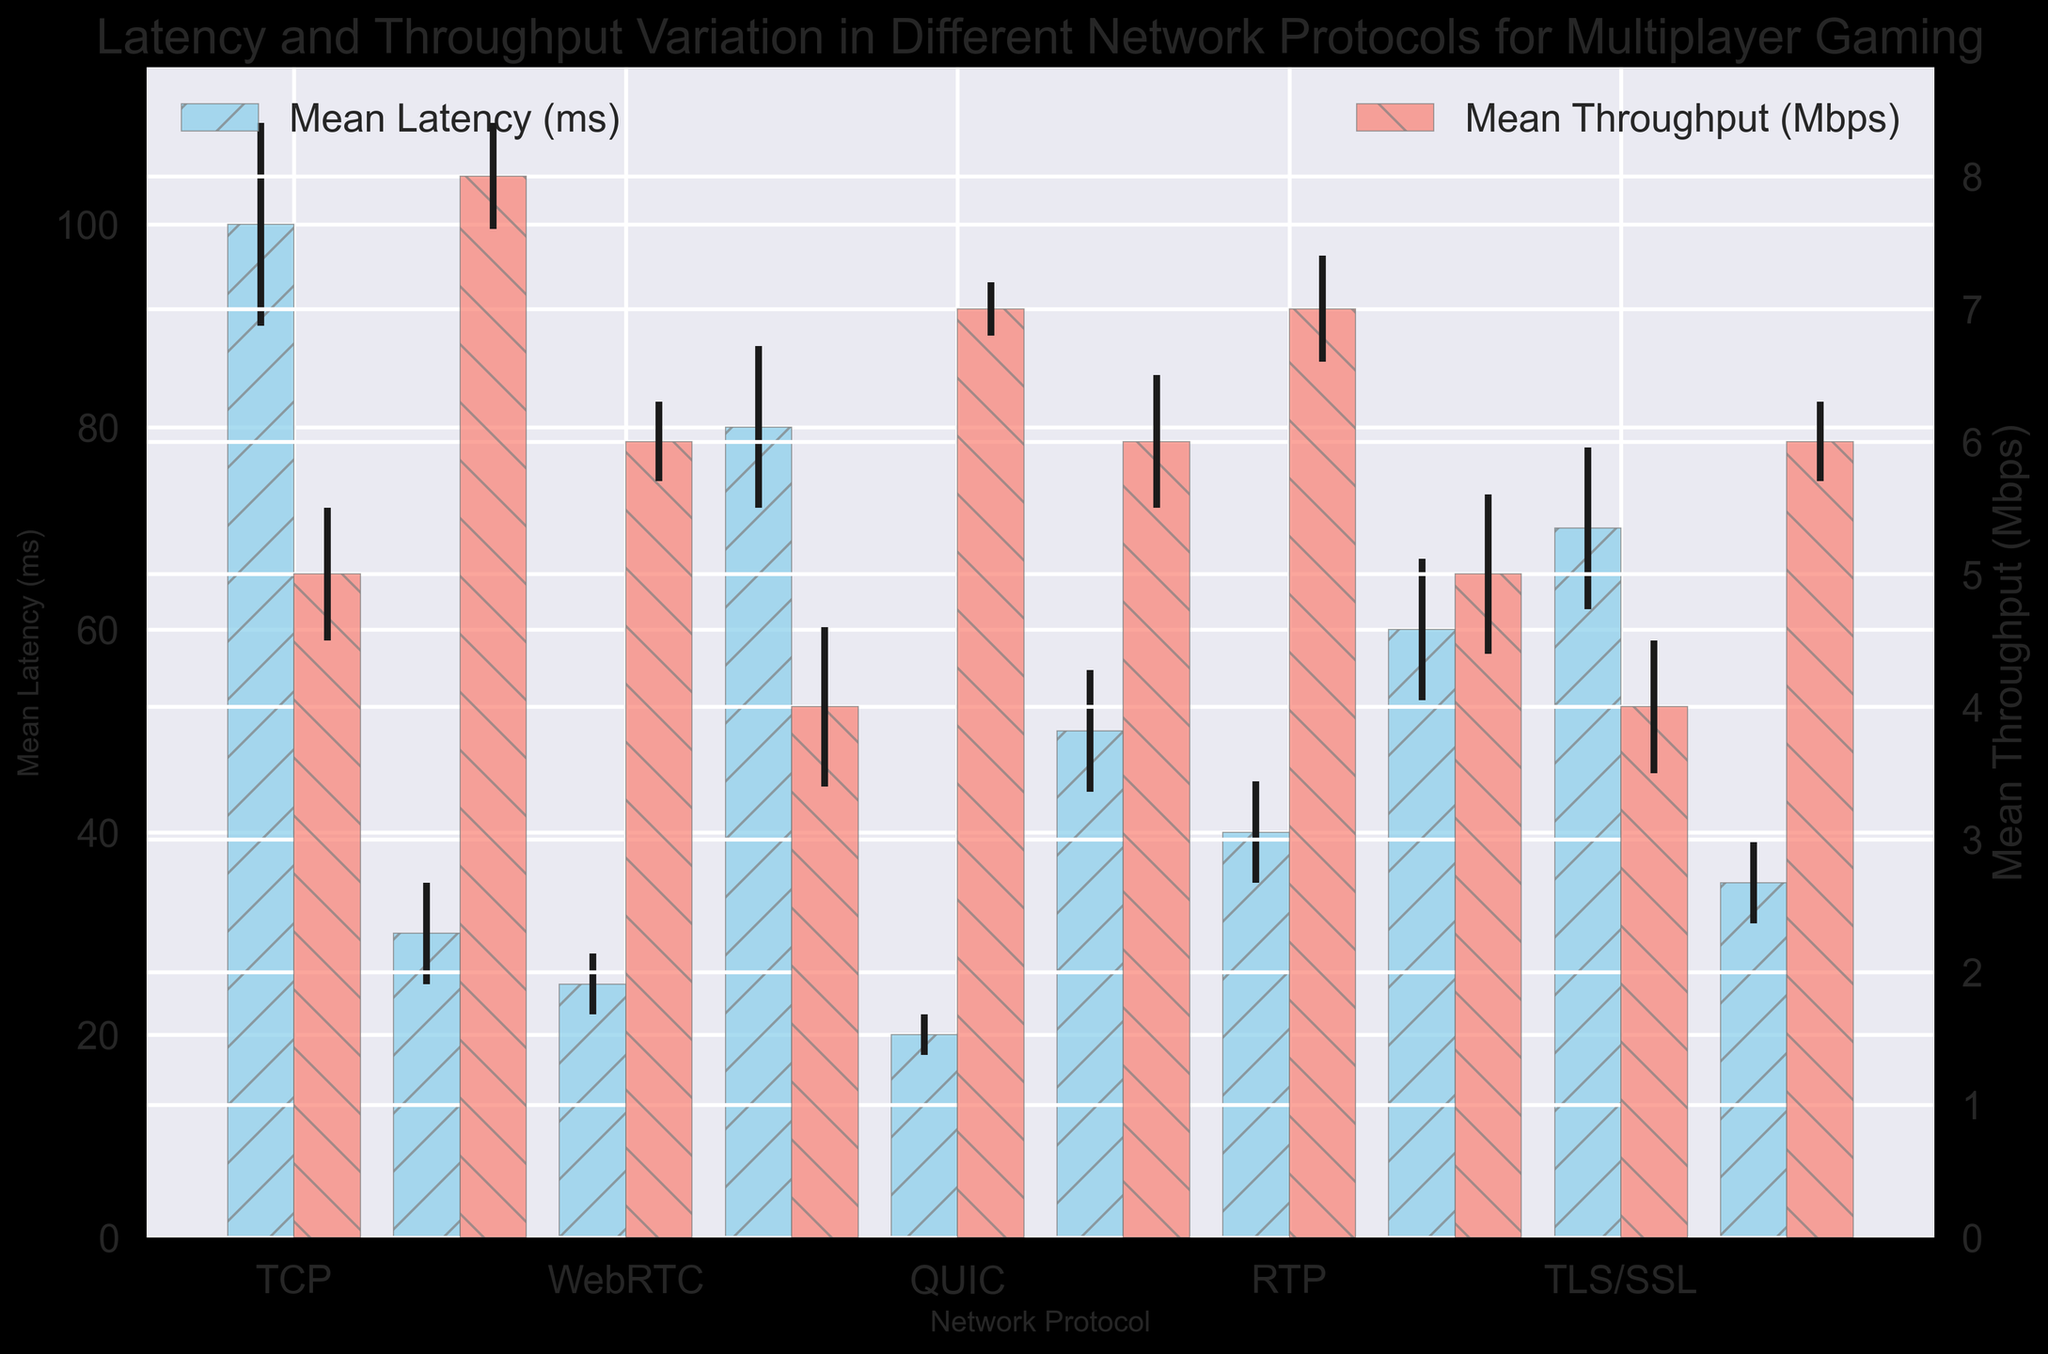Which protocol has the highest mean latency? To determine the protocol with the highest mean latency, examine the bar heights in the chart representing mean latency. The bar representing TCP is the tallest, indicating it has the highest mean latency.
Answer: TCP What is the difference in mean latency between QUIC and UDP? To find the difference, identify the heights of the latency bars for QUIC and UDP. QUIC has a mean latency of 20 ms, and UDP has 30 ms. The difference is 30 - 20 = 10 ms.
Answer: 10 ms Which protocol has the smallest mean throughput error? Check the error bars on the throughput bars to identify which one is smallest. The error bar for QUIC's throughput is the smallest, indicating it has the smallest mean throughput error.
Answer: QUIC What is the sum of mean latencies for WebRTC and HTTP/2? Look at the heights of the mean latency bars for WebRTC and HTTP/2. WebRTC has 25 ms, and HTTP/2 has 80 ms. The sum is 25 + 80 = 105 ms.
Answer: 105 ms Which protocol shows the second-lowest mean latency? To identify the protocol with the second-lowest mean latency, find the second shortest latency bar. The shortest bar is for QUIC, and the second shortest is for WebRTC with 25 ms.
Answer: WebRTC How does the throughput of RTP compare to that of SCTP? Compare the heights of the throughput bars for RTP and SCTP. Both bars are at the same height, indicating that RTP and SCTP have equal mean throughputs of 7 Mbps.
Answer: Equal What is the average mean throughput for UDP, QUIC, and MPLS? Compute the mean throughput for the three protocols and then find their average. UDP: 8 Mbps, QUIC: 7 Mbps, MPLS: 6 Mbps. The average is (8 + 7 + 6) / 3 = 21 / 3 = 7 Mbps.
Answer: 7 Mbps Which protocol has the longest error bar for latency? Examine the length of the error bars for latency. The longest one is for TCP, indicating it has the longest latency error bar.
Answer: TCP What is the ratio of mean latency between TLS/SSL and RTP? Identify the mean latency for TLS/SSL (70 ms) and RTP (40 ms) and then compute their ratio. The ratio is 70 / 40 = 1.75.
Answer: 1.75 How much higher is the mean throughput of UDP compared to HTTP/2? Find the height of the throughput bars for UDP and HTTP/2. UDP throughput is 8 Mbps and HTTP/2 is 4 Mbps. The difference is 8 - 4 = 4 Mbps.
Answer: 4 Mbps 